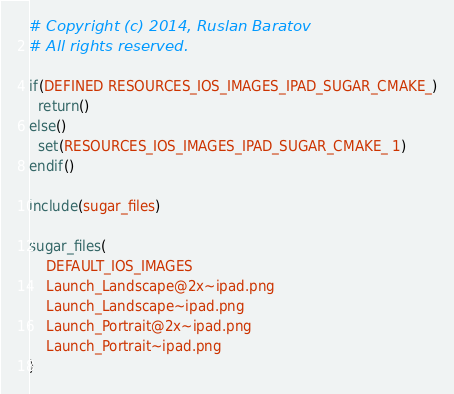<code> <loc_0><loc_0><loc_500><loc_500><_CMake_># Copyright (c) 2014, Ruslan Baratov
# All rights reserved.

if(DEFINED RESOURCES_IOS_IMAGES_IPAD_SUGAR_CMAKE_)
  return()
else()
  set(RESOURCES_IOS_IMAGES_IPAD_SUGAR_CMAKE_ 1)
endif()

include(sugar_files)

sugar_files(
    DEFAULT_IOS_IMAGES
    Launch_Landscape@2x~ipad.png
    Launch_Landscape~ipad.png
    Launch_Portrait@2x~ipad.png
    Launch_Portrait~ipad.png
)
</code> 